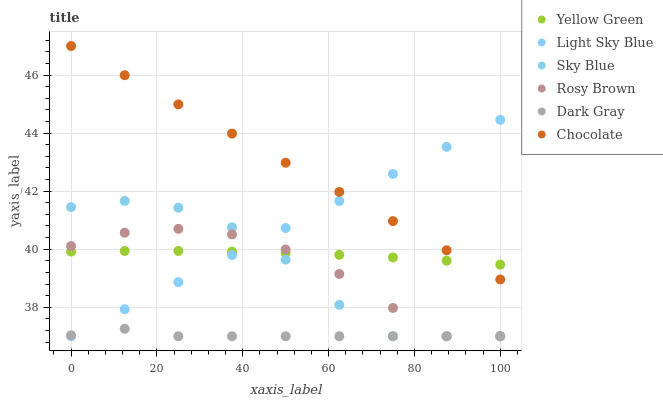Does Dark Gray have the minimum area under the curve?
Answer yes or no. Yes. Does Chocolate have the maximum area under the curve?
Answer yes or no. Yes. Does Rosy Brown have the minimum area under the curve?
Answer yes or no. No. Does Rosy Brown have the maximum area under the curve?
Answer yes or no. No. Is Chocolate the smoothest?
Answer yes or no. Yes. Is Sky Blue the roughest?
Answer yes or no. Yes. Is Rosy Brown the smoothest?
Answer yes or no. No. Is Rosy Brown the roughest?
Answer yes or no. No. Does Rosy Brown have the lowest value?
Answer yes or no. Yes. Does Chocolate have the lowest value?
Answer yes or no. No. Does Chocolate have the highest value?
Answer yes or no. Yes. Does Rosy Brown have the highest value?
Answer yes or no. No. Is Dark Gray less than Yellow Green?
Answer yes or no. Yes. Is Chocolate greater than Sky Blue?
Answer yes or no. Yes. Does Light Sky Blue intersect Dark Gray?
Answer yes or no. Yes. Is Light Sky Blue less than Dark Gray?
Answer yes or no. No. Is Light Sky Blue greater than Dark Gray?
Answer yes or no. No. Does Dark Gray intersect Yellow Green?
Answer yes or no. No. 